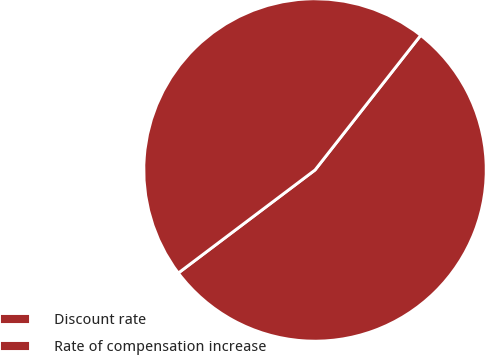Convert chart to OTSL. <chart><loc_0><loc_0><loc_500><loc_500><pie_chart><fcel>Discount rate<fcel>Rate of compensation increase<nl><fcel>54.13%<fcel>45.87%<nl></chart> 